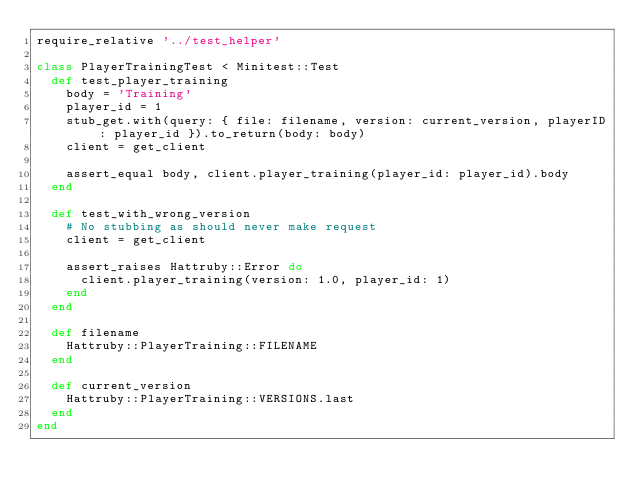Convert code to text. <code><loc_0><loc_0><loc_500><loc_500><_Ruby_>require_relative '../test_helper'

class PlayerTrainingTest < Minitest::Test
  def test_player_training
    body = 'Training'
    player_id = 1
    stub_get.with(query: { file: filename, version: current_version, playerID: player_id }).to_return(body: body)
    client = get_client

    assert_equal body, client.player_training(player_id: player_id).body
  end

  def test_with_wrong_version
    # No stubbing as should never make request
    client = get_client

    assert_raises Hattruby::Error do
      client.player_training(version: 1.0, player_id: 1)
    end
  end

  def filename
    Hattruby::PlayerTraining::FILENAME
  end

  def current_version
    Hattruby::PlayerTraining::VERSIONS.last
  end
end
</code> 